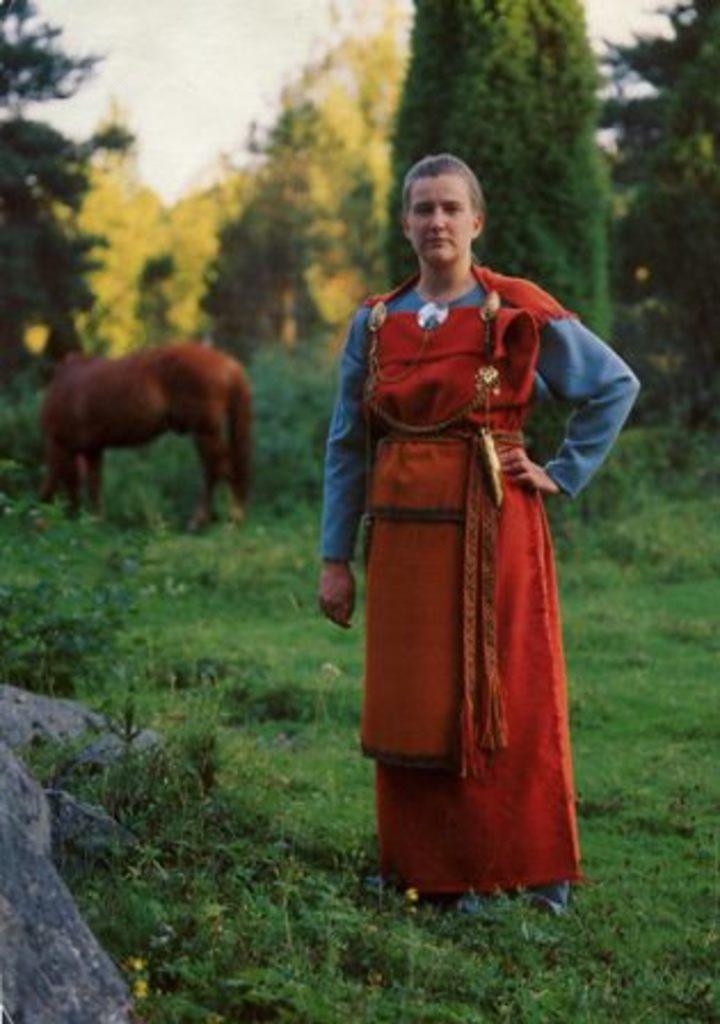In one or two sentences, can you explain what this image depicts? There is a lady standing on the grasses. In the back there is a horse. Also there are trees and sky. On the left corner there is a rock. 